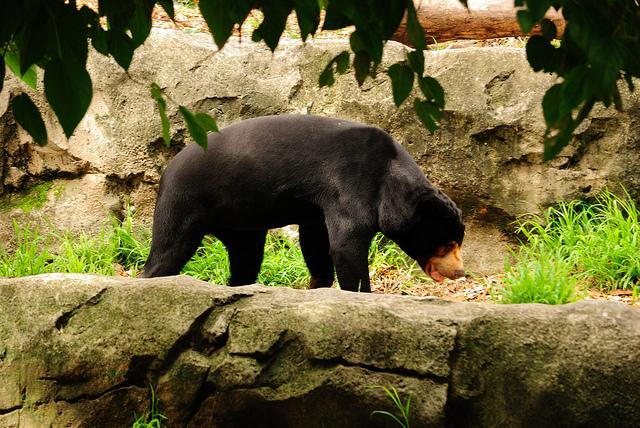How many tufts of grass are below the bear?
Write a very short answer. 2. Is this a polar bear?
Answer briefly. No. What is the bear standing on?
Short answer required. Rock. 